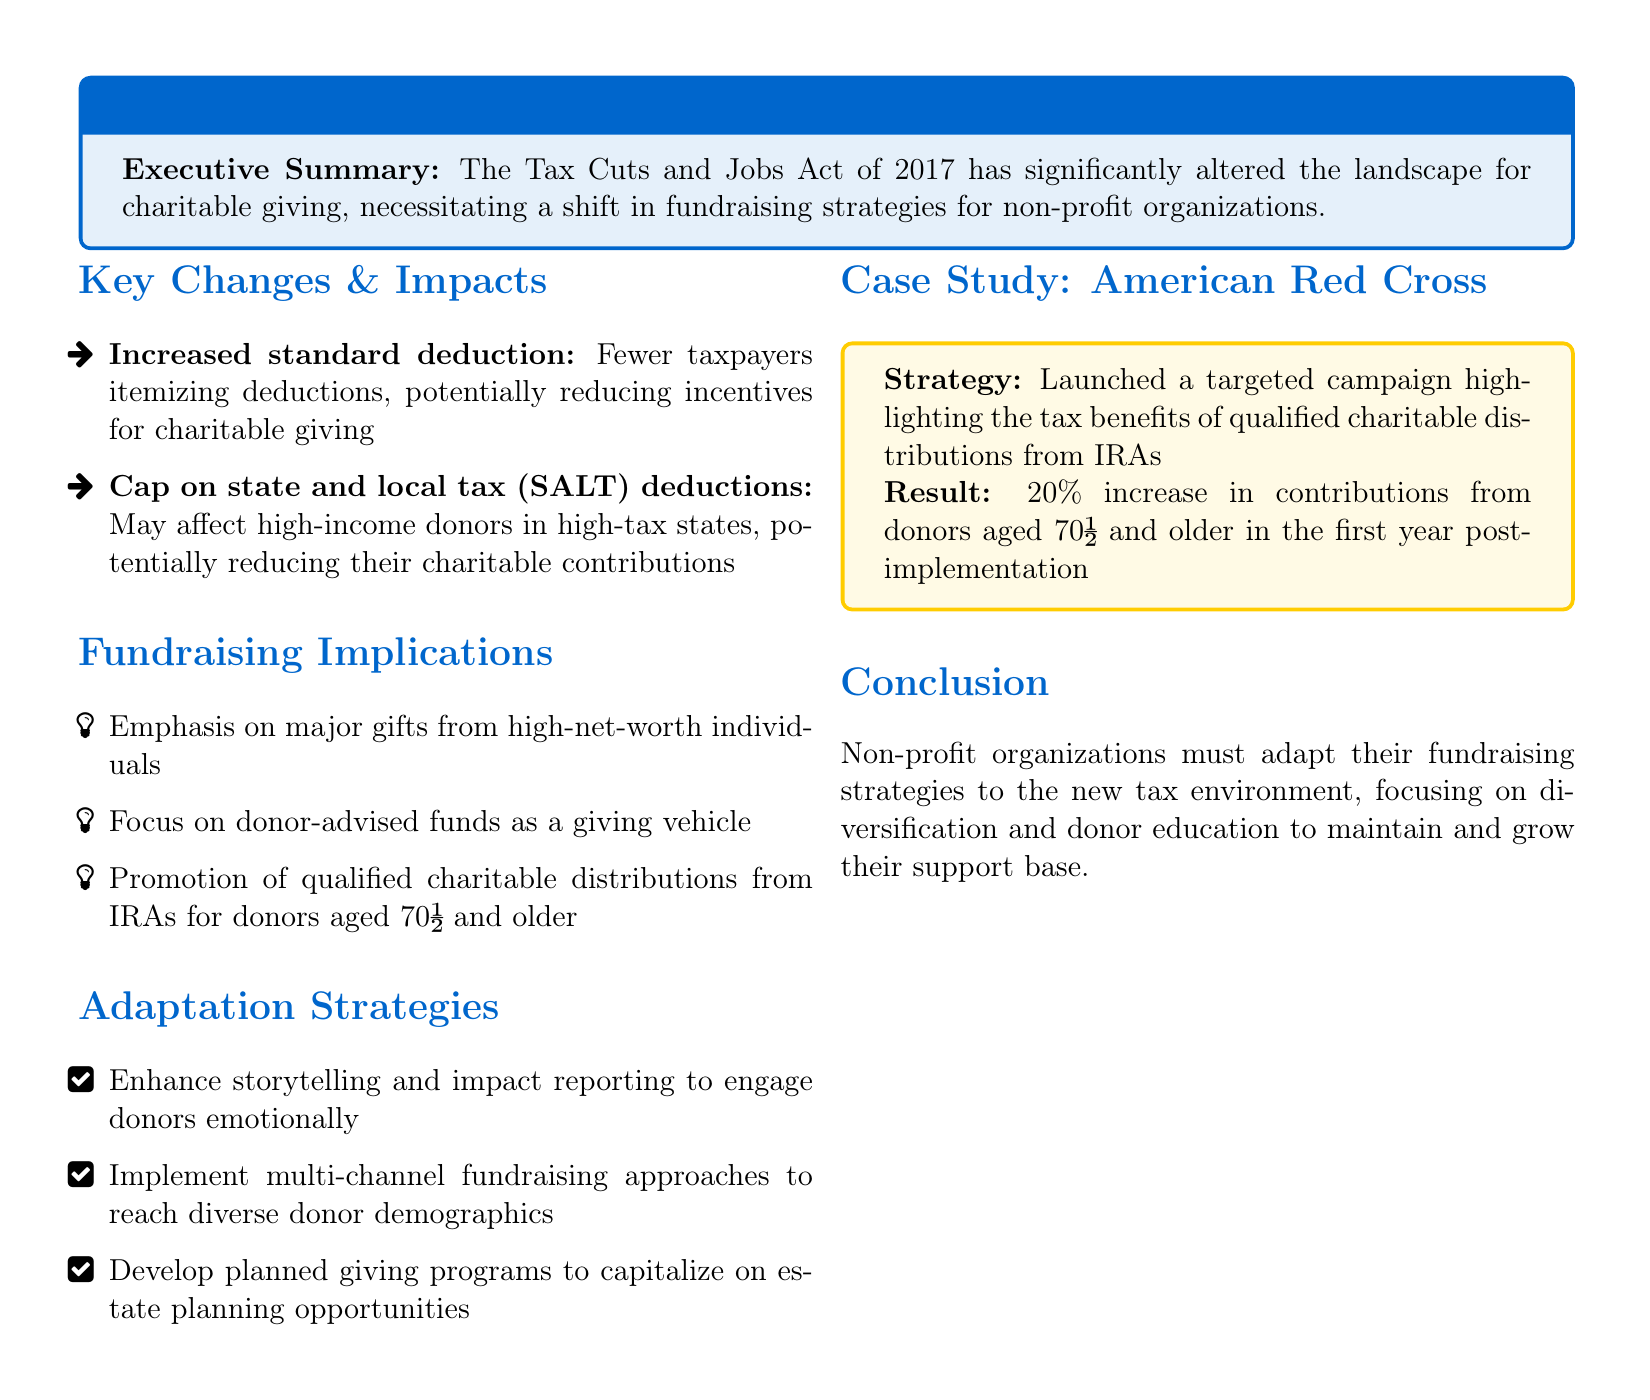what is the title of the document? The title is given in the heading of the document which is related to the impact of tax law changes on non-profit fundraising.
Answer: Impact of Recent Tax Law Changes on Non-Profit Fundraising Strategies what is the main tax law discussed in the document? The document discusses the Tax Cuts and Jobs Act of 2017, which is central to the findings.
Answer: Tax Cuts and Jobs Act of 2017 how may high-income donors be affected according to the document? The document mentions a cap on state and local tax deductions that could impact high-income donors in high-tax states.
Answer: Reducing charitable contributions what strategy did the American Red Cross implement? The case study highlights a specific strategy they launched regarding tax benefits from qualified charitable distributions.
Answer: Targeted campaign what was the result of the American Red Cross's strategy in the first year? The document states a specific percentage increase in contributions from a defined donor demographic post-implementation.
Answer: 20% increase which demographic is highlighted as a focus for enhanced fundraising strategies? The document indicates a specific age group that is particularly targeted for contributions and strategies.
Answer: Donors aged 70½ and older what type of fundraising approach is recommended for non-profits? The document lists a specific strategy that involves reaching a variety of donor demographics through multiple channels.
Answer: Multi-channel fundraising approaches what emotional engagement strategy is suggested in the document? The document recommends a particular method to emotionally involve donors and enhance engagement.
Answer: Storytelling and impact reporting what should non-profit organizations focus on according to the conclusion? The conclusion suggests a need for a specific focus area for non-profit organizations to thrive in the new tax environment.
Answer: Diversification and donor education 